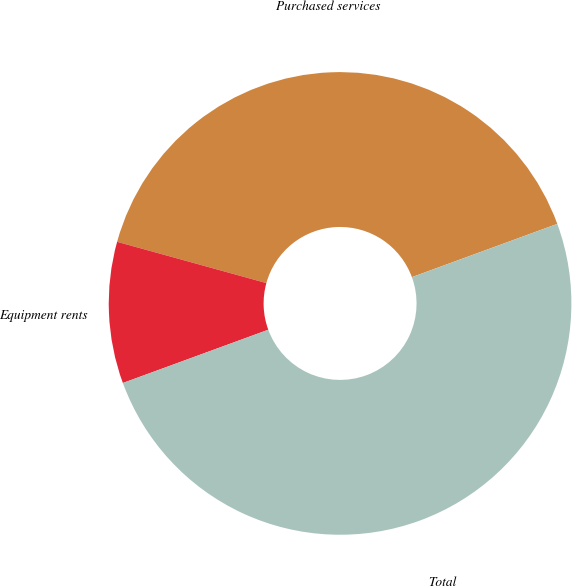Convert chart to OTSL. <chart><loc_0><loc_0><loc_500><loc_500><pie_chart><fcel>Purchased services<fcel>Equipment rents<fcel>Total<nl><fcel>40.12%<fcel>9.88%<fcel>50.0%<nl></chart> 